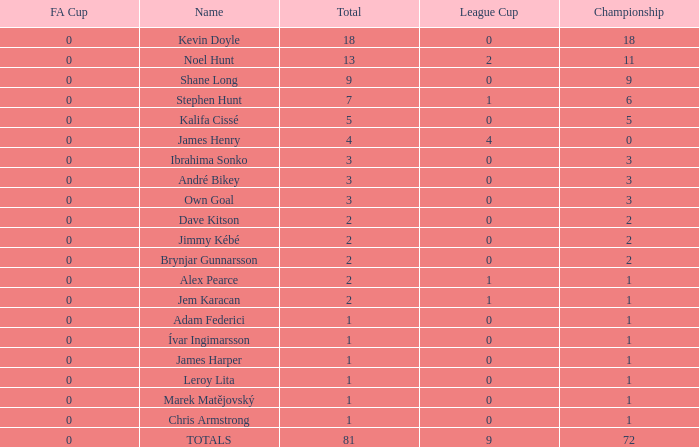What is the championship of Jem Karacan that has a total of 2 and a league cup more than 0? 1.0. 